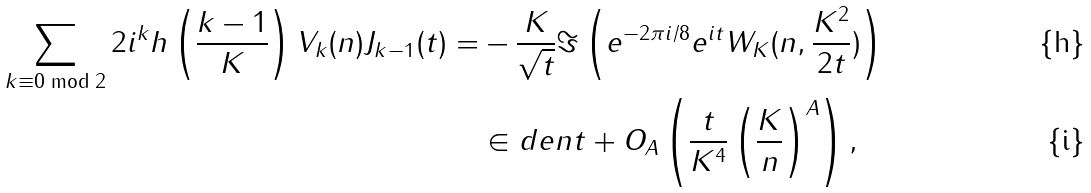Convert formula to latex. <formula><loc_0><loc_0><loc_500><loc_500>\sum _ { k \equiv 0 \bmod 2 } 2 i ^ { k } h \left ( \frac { k - 1 } { K } \right ) V _ { k } ( n ) J _ { k - 1 } ( t ) = & - \frac { K } { \sqrt { t } } \Im \left ( e ^ { - 2 \pi i / 8 } e ^ { i t } W _ { K } ( n , \frac { K ^ { 2 } } { 2 t } ) \right ) \\ & \in d e n t + O _ { A } \left ( \frac { t } { K ^ { 4 } } \left ( \frac { K } { n } \right ) ^ { A } \right ) ,</formula> 